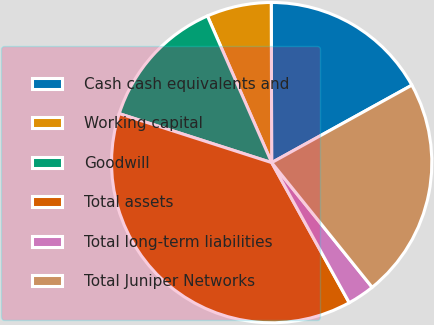<chart> <loc_0><loc_0><loc_500><loc_500><pie_chart><fcel>Cash cash equivalents and<fcel>Working capital<fcel>Goodwill<fcel>Total assets<fcel>Total long-term liabilities<fcel>Total Juniper Networks<nl><fcel>17.01%<fcel>6.53%<fcel>13.48%<fcel>38.0%<fcel>2.75%<fcel>22.24%<nl></chart> 